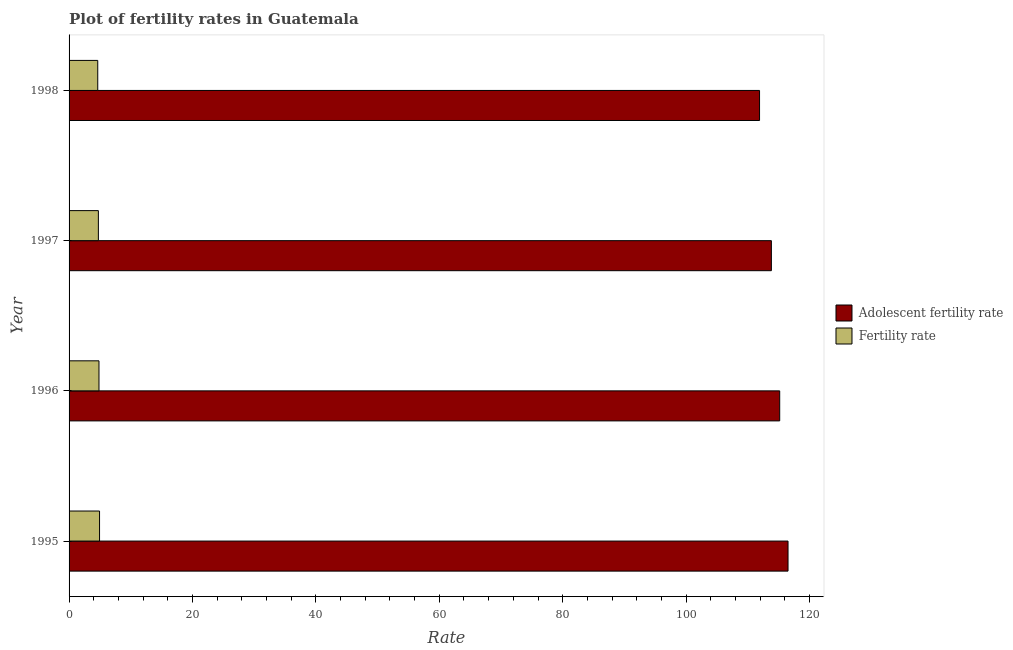How many groups of bars are there?
Give a very brief answer. 4. Are the number of bars on each tick of the Y-axis equal?
Give a very brief answer. Yes. How many bars are there on the 1st tick from the top?
Provide a succinct answer. 2. How many bars are there on the 1st tick from the bottom?
Provide a succinct answer. 2. What is the adolescent fertility rate in 1997?
Your answer should be compact. 113.83. Across all years, what is the maximum fertility rate?
Provide a short and direct response. 4.94. Across all years, what is the minimum fertility rate?
Keep it short and to the point. 4.65. In which year was the adolescent fertility rate maximum?
Make the answer very short. 1995. What is the total fertility rate in the graph?
Your response must be concise. 19.18. What is the difference between the fertility rate in 1995 and that in 1997?
Provide a succinct answer. 0.19. What is the difference between the adolescent fertility rate in 1995 and the fertility rate in 1996?
Offer a terse response. 111.68. What is the average fertility rate per year?
Provide a short and direct response. 4.8. In the year 1996, what is the difference between the adolescent fertility rate and fertility rate?
Ensure brevity in your answer.  110.33. What is the ratio of the adolescent fertility rate in 1996 to that in 1997?
Your response must be concise. 1.01. Is the adolescent fertility rate in 1996 less than that in 1998?
Make the answer very short. No. What is the difference between the highest and the second highest fertility rate?
Your answer should be very brief. 0.09. What is the difference between the highest and the lowest adolescent fertility rate?
Your answer should be compact. 4.62. In how many years, is the fertility rate greater than the average fertility rate taken over all years?
Your answer should be very brief. 2. What does the 2nd bar from the top in 1997 represents?
Provide a succinct answer. Adolescent fertility rate. What does the 1st bar from the bottom in 1996 represents?
Offer a very short reply. Adolescent fertility rate. How many bars are there?
Your answer should be very brief. 8. Are all the bars in the graph horizontal?
Your response must be concise. Yes. How many years are there in the graph?
Make the answer very short. 4. Where does the legend appear in the graph?
Your answer should be compact. Center right. How are the legend labels stacked?
Keep it short and to the point. Vertical. What is the title of the graph?
Provide a short and direct response. Plot of fertility rates in Guatemala. What is the label or title of the X-axis?
Your answer should be compact. Rate. What is the Rate in Adolescent fertility rate in 1995?
Give a very brief answer. 116.52. What is the Rate in Fertility rate in 1995?
Your response must be concise. 4.94. What is the Rate of Adolescent fertility rate in 1996?
Ensure brevity in your answer.  115.17. What is the Rate in Fertility rate in 1996?
Offer a very short reply. 4.85. What is the Rate in Adolescent fertility rate in 1997?
Give a very brief answer. 113.83. What is the Rate of Fertility rate in 1997?
Offer a very short reply. 4.75. What is the Rate of Adolescent fertility rate in 1998?
Provide a succinct answer. 111.91. What is the Rate of Fertility rate in 1998?
Offer a very short reply. 4.65. Across all years, what is the maximum Rate in Adolescent fertility rate?
Give a very brief answer. 116.52. Across all years, what is the maximum Rate in Fertility rate?
Offer a very short reply. 4.94. Across all years, what is the minimum Rate of Adolescent fertility rate?
Make the answer very short. 111.91. Across all years, what is the minimum Rate of Fertility rate?
Your response must be concise. 4.65. What is the total Rate in Adolescent fertility rate in the graph?
Offer a terse response. 457.43. What is the total Rate in Fertility rate in the graph?
Provide a succinct answer. 19.18. What is the difference between the Rate of Adolescent fertility rate in 1995 and that in 1996?
Provide a short and direct response. 1.35. What is the difference between the Rate of Fertility rate in 1995 and that in 1996?
Give a very brief answer. 0.09. What is the difference between the Rate in Adolescent fertility rate in 1995 and that in 1997?
Make the answer very short. 2.7. What is the difference between the Rate in Fertility rate in 1995 and that in 1997?
Ensure brevity in your answer.  0.19. What is the difference between the Rate of Adolescent fertility rate in 1995 and that in 1998?
Offer a very short reply. 4.62. What is the difference between the Rate in Fertility rate in 1995 and that in 1998?
Your response must be concise. 0.29. What is the difference between the Rate in Adolescent fertility rate in 1996 and that in 1997?
Give a very brief answer. 1.35. What is the difference between the Rate in Fertility rate in 1996 and that in 1997?
Ensure brevity in your answer.  0.1. What is the difference between the Rate in Adolescent fertility rate in 1996 and that in 1998?
Your answer should be very brief. 3.27. What is the difference between the Rate in Fertility rate in 1996 and that in 1998?
Your answer should be compact. 0.2. What is the difference between the Rate in Adolescent fertility rate in 1997 and that in 1998?
Ensure brevity in your answer.  1.92. What is the difference between the Rate of Fertility rate in 1997 and that in 1998?
Your response must be concise. 0.1. What is the difference between the Rate in Adolescent fertility rate in 1995 and the Rate in Fertility rate in 1996?
Provide a succinct answer. 111.68. What is the difference between the Rate in Adolescent fertility rate in 1995 and the Rate in Fertility rate in 1997?
Provide a succinct answer. 111.77. What is the difference between the Rate of Adolescent fertility rate in 1995 and the Rate of Fertility rate in 1998?
Offer a terse response. 111.88. What is the difference between the Rate of Adolescent fertility rate in 1996 and the Rate of Fertility rate in 1997?
Provide a short and direct response. 110.42. What is the difference between the Rate of Adolescent fertility rate in 1996 and the Rate of Fertility rate in 1998?
Keep it short and to the point. 110.53. What is the difference between the Rate of Adolescent fertility rate in 1997 and the Rate of Fertility rate in 1998?
Offer a terse response. 109.18. What is the average Rate in Adolescent fertility rate per year?
Your answer should be very brief. 114.36. What is the average Rate in Fertility rate per year?
Your answer should be compact. 4.8. In the year 1995, what is the difference between the Rate in Adolescent fertility rate and Rate in Fertility rate?
Make the answer very short. 111.59. In the year 1996, what is the difference between the Rate in Adolescent fertility rate and Rate in Fertility rate?
Ensure brevity in your answer.  110.33. In the year 1997, what is the difference between the Rate in Adolescent fertility rate and Rate in Fertility rate?
Provide a short and direct response. 109.08. In the year 1998, what is the difference between the Rate of Adolescent fertility rate and Rate of Fertility rate?
Make the answer very short. 107.26. What is the ratio of the Rate in Adolescent fertility rate in 1995 to that in 1996?
Your response must be concise. 1.01. What is the ratio of the Rate of Adolescent fertility rate in 1995 to that in 1997?
Your answer should be very brief. 1.02. What is the ratio of the Rate in Fertility rate in 1995 to that in 1997?
Provide a short and direct response. 1.04. What is the ratio of the Rate in Adolescent fertility rate in 1995 to that in 1998?
Keep it short and to the point. 1.04. What is the ratio of the Rate in Fertility rate in 1995 to that in 1998?
Provide a succinct answer. 1.06. What is the ratio of the Rate in Adolescent fertility rate in 1996 to that in 1997?
Keep it short and to the point. 1.01. What is the ratio of the Rate of Fertility rate in 1996 to that in 1997?
Offer a very short reply. 1.02. What is the ratio of the Rate of Adolescent fertility rate in 1996 to that in 1998?
Your response must be concise. 1.03. What is the ratio of the Rate in Fertility rate in 1996 to that in 1998?
Make the answer very short. 1.04. What is the ratio of the Rate in Adolescent fertility rate in 1997 to that in 1998?
Give a very brief answer. 1.02. What is the ratio of the Rate in Fertility rate in 1997 to that in 1998?
Keep it short and to the point. 1.02. What is the difference between the highest and the second highest Rate of Adolescent fertility rate?
Your answer should be compact. 1.35. What is the difference between the highest and the second highest Rate in Fertility rate?
Your answer should be compact. 0.09. What is the difference between the highest and the lowest Rate in Adolescent fertility rate?
Offer a terse response. 4.62. What is the difference between the highest and the lowest Rate in Fertility rate?
Provide a short and direct response. 0.29. 